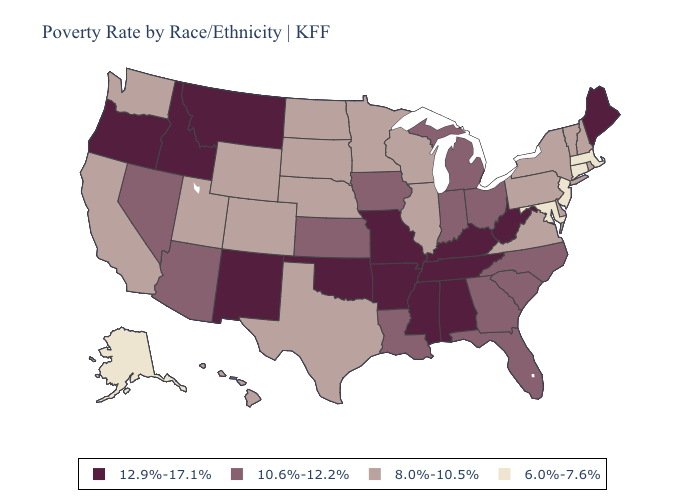What is the highest value in the South ?
Short answer required. 12.9%-17.1%. What is the lowest value in the USA?
Keep it brief. 6.0%-7.6%. Name the states that have a value in the range 12.9%-17.1%?
Concise answer only. Alabama, Arkansas, Idaho, Kentucky, Maine, Mississippi, Missouri, Montana, New Mexico, Oklahoma, Oregon, Tennessee, West Virginia. Which states hav the highest value in the Northeast?
Answer briefly. Maine. What is the lowest value in states that border Nebraska?
Answer briefly. 8.0%-10.5%. Name the states that have a value in the range 10.6%-12.2%?
Concise answer only. Arizona, Florida, Georgia, Indiana, Iowa, Kansas, Louisiana, Michigan, Nevada, North Carolina, Ohio, South Carolina. What is the value of Arizona?
Keep it brief. 10.6%-12.2%. What is the highest value in states that border Indiana?
Short answer required. 12.9%-17.1%. Name the states that have a value in the range 12.9%-17.1%?
Keep it brief. Alabama, Arkansas, Idaho, Kentucky, Maine, Mississippi, Missouri, Montana, New Mexico, Oklahoma, Oregon, Tennessee, West Virginia. What is the value of Vermont?
Concise answer only. 8.0%-10.5%. Does Idaho have a higher value than Kentucky?
Give a very brief answer. No. What is the value of Utah?
Short answer required. 8.0%-10.5%. Name the states that have a value in the range 6.0%-7.6%?
Concise answer only. Alaska, Connecticut, Maryland, Massachusetts, New Jersey. What is the value of Michigan?
Write a very short answer. 10.6%-12.2%. Among the states that border Nebraska , does Colorado have the highest value?
Keep it brief. No. 